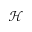<formula> <loc_0><loc_0><loc_500><loc_500>\mathcal { H }</formula> 